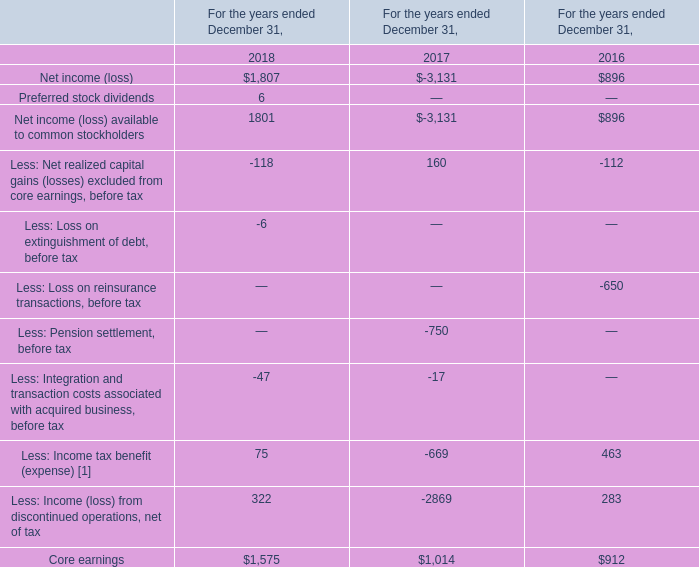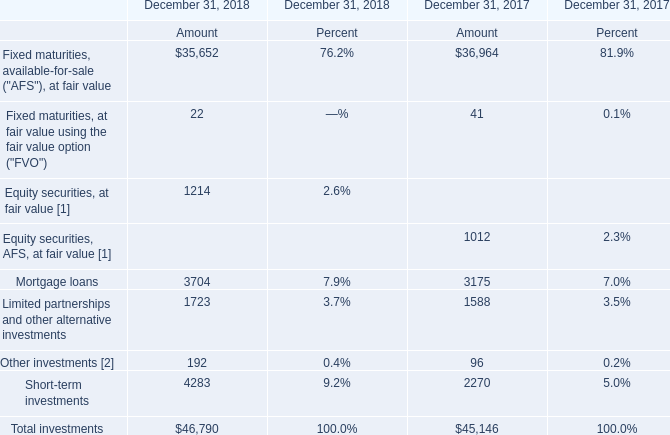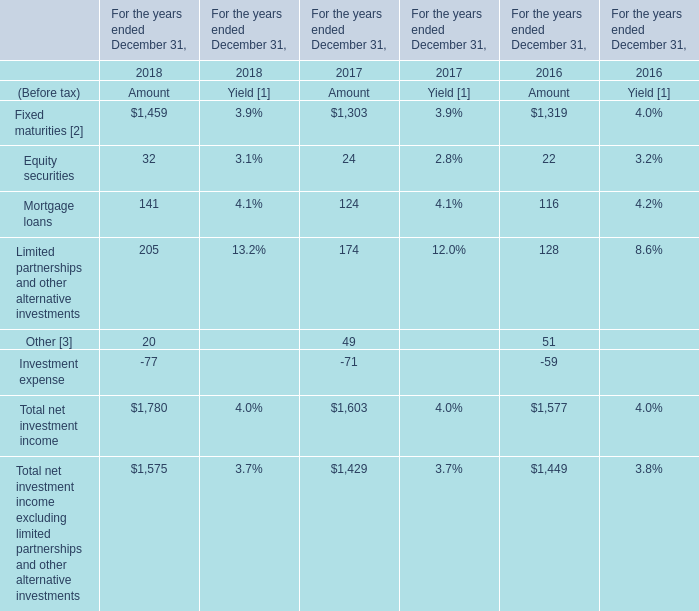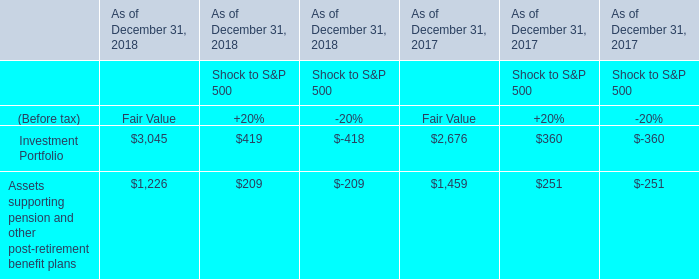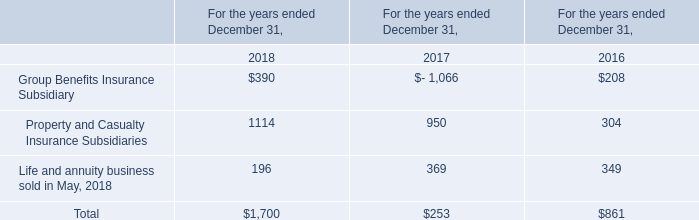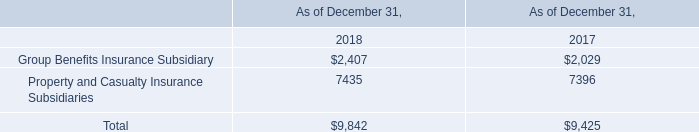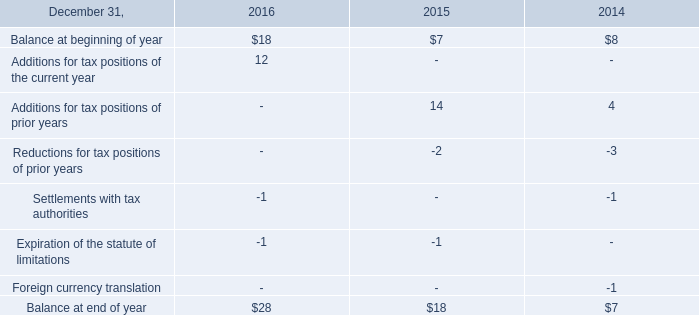What is the total amount of Mortgage loans of December 31, 2018 Amount, and Core earnings of For the years ended December 31, 2018 ? 
Computations: (3704.0 + 1575.0)
Answer: 5279.0. 